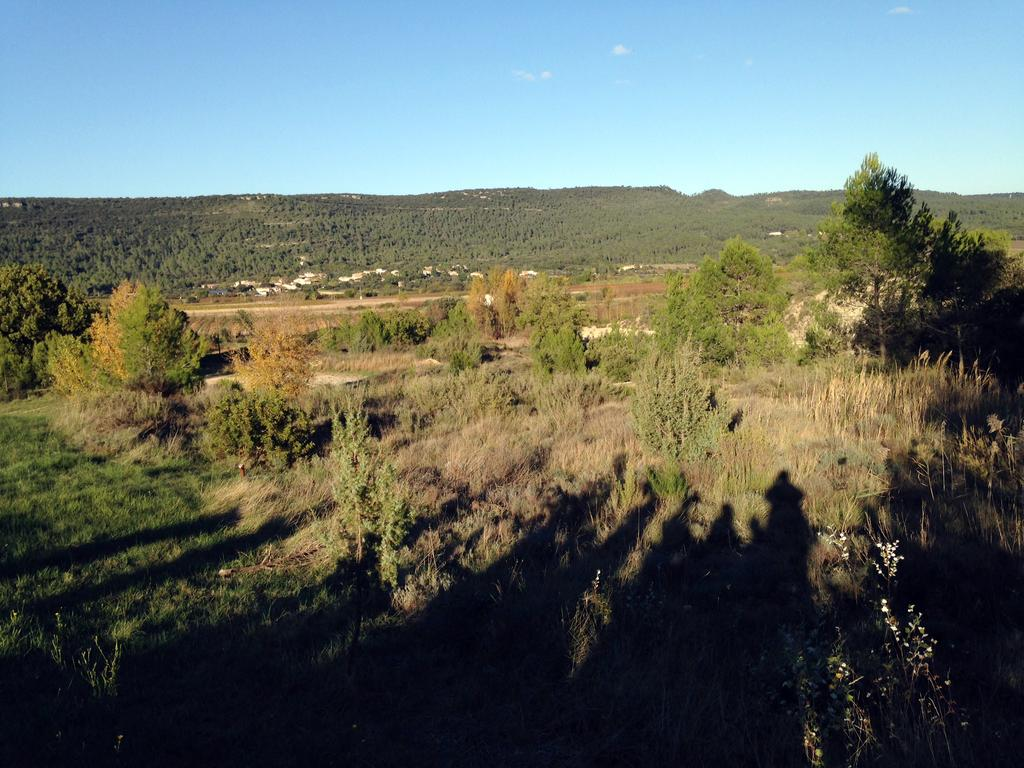What type of vegetation is at the bottom of the image? There is grass, plants, and trees at the bottom of the image. What structures can be seen in the background of the image? There are houses and trees in the background of the image. What natural landmark is visible in the background of the image? There are mountains in the background of the image. What part of the natural environment is visible at the top of the image? The sky is visible at the top of the image. What color is the ink spilled by the ghost in the image? There is no ink or ghost present in the image. Is the veil covering any part of the image? There is no veil present in the image. 